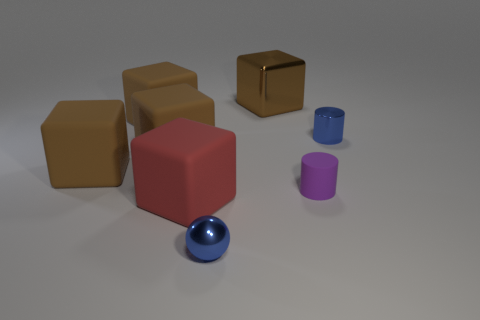Subtract all purple cylinders. How many brown blocks are left? 4 Subtract all red blocks. How many blocks are left? 4 Subtract all big metal blocks. How many blocks are left? 4 Subtract all green cubes. Subtract all blue balls. How many cubes are left? 5 Add 1 shiny blocks. How many objects exist? 9 Subtract all balls. How many objects are left? 7 Subtract all brown matte balls. Subtract all metal cylinders. How many objects are left? 7 Add 1 red things. How many red things are left? 2 Add 5 large blue cubes. How many large blue cubes exist? 5 Subtract 0 purple cubes. How many objects are left? 8 